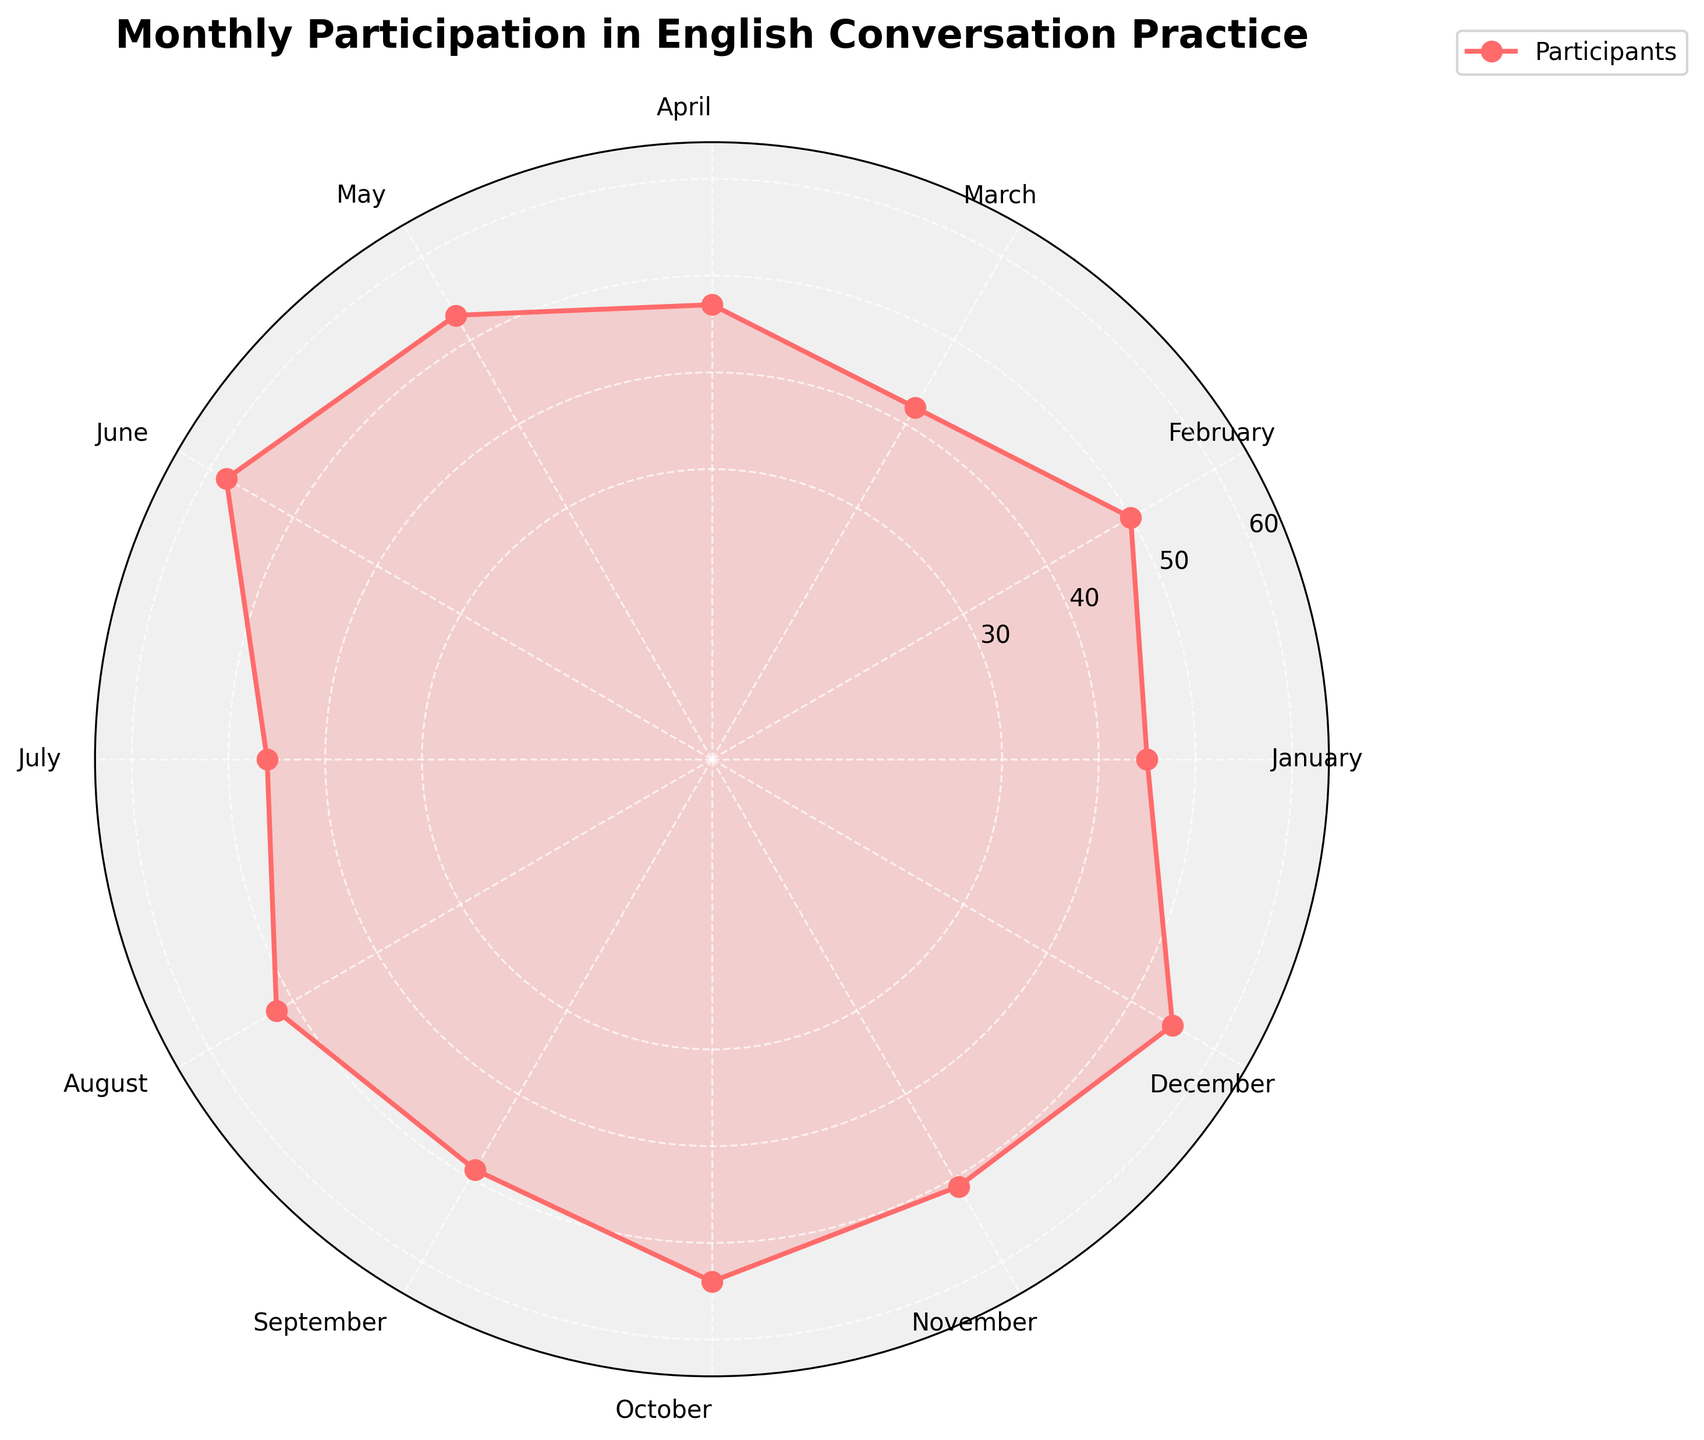What is the title of the rose chart? The title of the rose chart is displayed at the top of the figure, summing up the overall content
Answer: Monthly Participation in English Conversation Practice What is the highest monthly participation? The highest point on the chart represents the maximum value, which occurs in June
Answer: 58 How many months have over 50 participants? Count the number of months where the data points exceed 50 on the chart: February, May, June, August, October, November, December
Answer: 7 Which month had the second lowest participation? By visually identifying the second shortest radius, it corresponds to March with 42 participants
Answer: March What is the average monthly participation rate? Sum the number of participants for all months and divide by 12: (45 + 50 + 42 + 47 + 53 + 58 + 46 + 52 + 49 + 54 + 51 + 55) / 12 = 50.25
Answer: 50.25 Which month had a higher participation rate, January or July? Compare the data points for January and July by visually comparing their lengths from the center: January has 45 and July has 46
Answer: July What is the difference in participation between the highest and lowest months? Subtract the minimum value from the maximum value observed in the chart: 58 (June) - 42 (March) = 16
Answer: 16 What trend can you observe from May to August? Observe the plot lines from May to August; the participation decreases from May (53) to July (46) and then increases in August (52)
Answer: Decrease, then Increase Which month shows the lowest participation in the second half of the year? Identify the lowest data point among July to December: July with 46 participants
Answer: July How does the participation in October compare to the average monthly participation rate? October has 54 participants while the average is 50.25, compare and conclude if it's higher or lower
Answer: Higher 